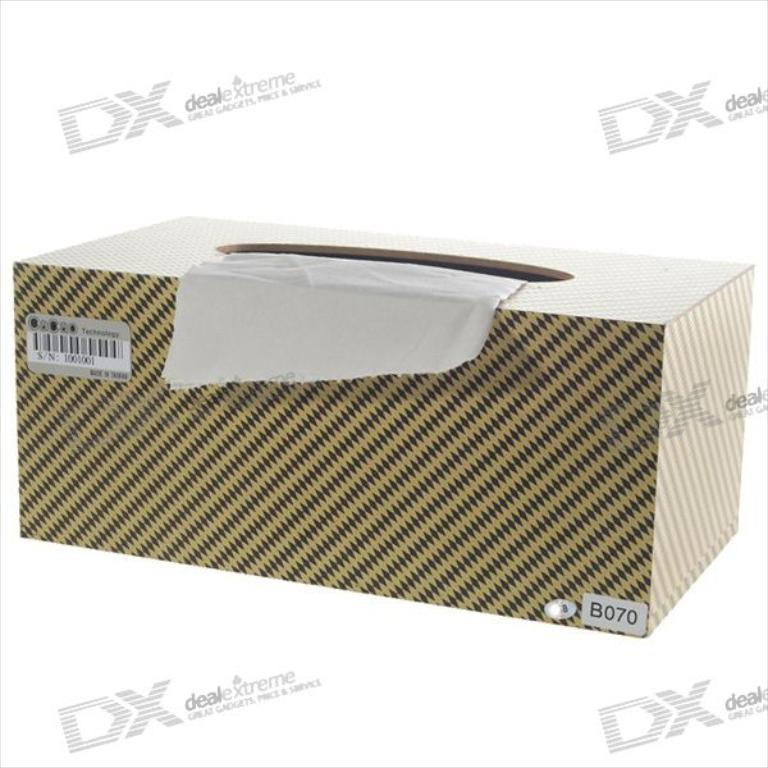Provide a one-sentence caption for the provided image. A box of tissues surrounded by watermarks for DX: Deal Extreme. 